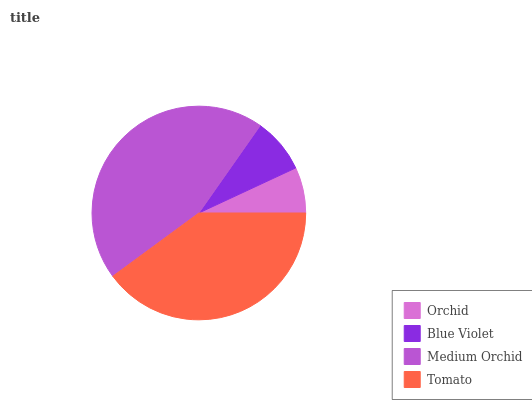Is Orchid the minimum?
Answer yes or no. Yes. Is Medium Orchid the maximum?
Answer yes or no. Yes. Is Blue Violet the minimum?
Answer yes or no. No. Is Blue Violet the maximum?
Answer yes or no. No. Is Blue Violet greater than Orchid?
Answer yes or no. Yes. Is Orchid less than Blue Violet?
Answer yes or no. Yes. Is Orchid greater than Blue Violet?
Answer yes or no. No. Is Blue Violet less than Orchid?
Answer yes or no. No. Is Tomato the high median?
Answer yes or no. Yes. Is Blue Violet the low median?
Answer yes or no. Yes. Is Medium Orchid the high median?
Answer yes or no. No. Is Tomato the low median?
Answer yes or no. No. 